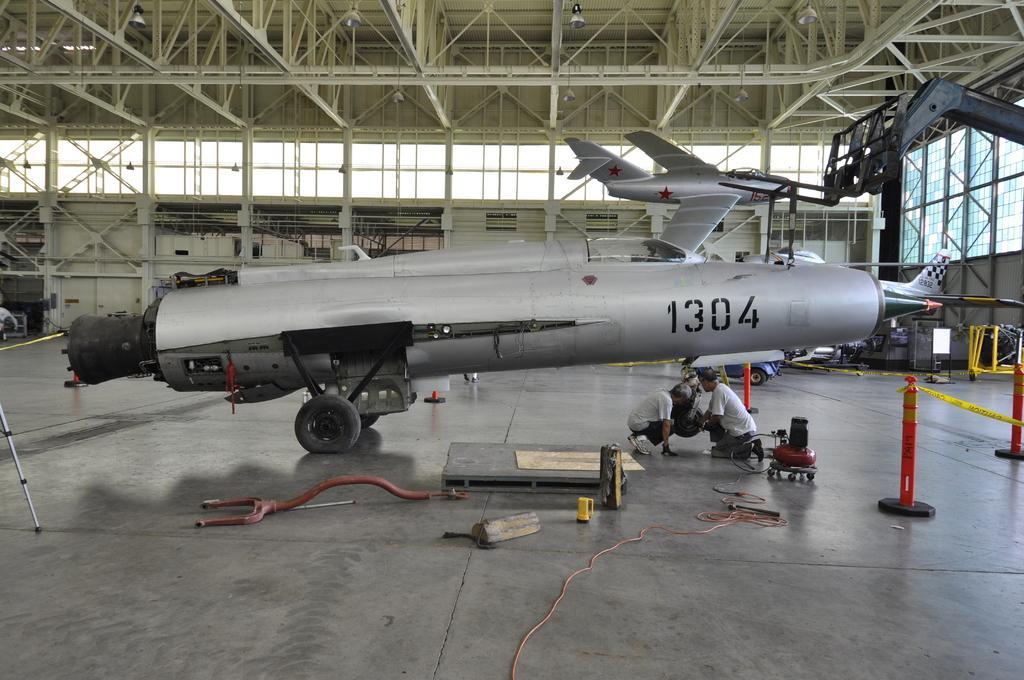Can you describe this image briefly? In this picture we can see an aircraft. There are two people and a few objects visible on the ground. There are some rods and a yellow tape on these rods on the right side. We can see a stand on the left side. There are a few things visible in the background. We can see some lights on top. 